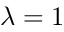Convert formula to latex. <formula><loc_0><loc_0><loc_500><loc_500>\lambda = 1</formula> 